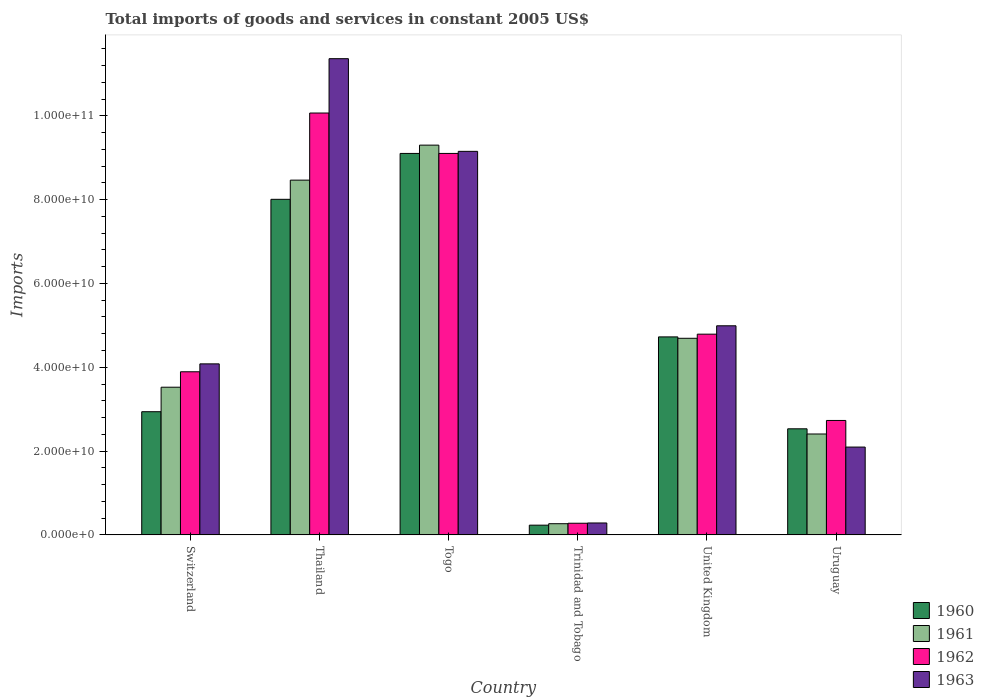Are the number of bars on each tick of the X-axis equal?
Your answer should be compact. Yes. How many bars are there on the 1st tick from the left?
Make the answer very short. 4. How many bars are there on the 4th tick from the right?
Provide a succinct answer. 4. What is the label of the 5th group of bars from the left?
Your answer should be very brief. United Kingdom. What is the total imports of goods and services in 1961 in Uruguay?
Provide a short and direct response. 2.41e+1. Across all countries, what is the maximum total imports of goods and services in 1961?
Keep it short and to the point. 9.30e+1. Across all countries, what is the minimum total imports of goods and services in 1963?
Keep it short and to the point. 2.85e+09. In which country was the total imports of goods and services in 1960 maximum?
Your response must be concise. Togo. In which country was the total imports of goods and services in 1961 minimum?
Your answer should be very brief. Trinidad and Tobago. What is the total total imports of goods and services in 1961 in the graph?
Your answer should be compact. 2.87e+11. What is the difference between the total imports of goods and services in 1961 in Trinidad and Tobago and that in Uruguay?
Your answer should be very brief. -2.14e+1. What is the difference between the total imports of goods and services in 1963 in United Kingdom and the total imports of goods and services in 1960 in Thailand?
Offer a terse response. -3.02e+1. What is the average total imports of goods and services in 1960 per country?
Provide a succinct answer. 4.59e+1. What is the difference between the total imports of goods and services of/in 1963 and total imports of goods and services of/in 1962 in Uruguay?
Provide a succinct answer. -6.35e+09. What is the ratio of the total imports of goods and services in 1960 in Switzerland to that in Uruguay?
Make the answer very short. 1.16. Is the difference between the total imports of goods and services in 1963 in Thailand and Trinidad and Tobago greater than the difference between the total imports of goods and services in 1962 in Thailand and Trinidad and Tobago?
Make the answer very short. Yes. What is the difference between the highest and the second highest total imports of goods and services in 1960?
Offer a terse response. -4.38e+1. What is the difference between the highest and the lowest total imports of goods and services in 1963?
Your answer should be very brief. 1.11e+11. Is the sum of the total imports of goods and services in 1963 in Thailand and Uruguay greater than the maximum total imports of goods and services in 1960 across all countries?
Offer a very short reply. Yes. What does the 4th bar from the right in Togo represents?
Your response must be concise. 1960. Is it the case that in every country, the sum of the total imports of goods and services in 1962 and total imports of goods and services in 1963 is greater than the total imports of goods and services in 1961?
Your answer should be compact. Yes. How many bars are there?
Your response must be concise. 24. Does the graph contain any zero values?
Make the answer very short. No. Does the graph contain grids?
Your answer should be very brief. No. Where does the legend appear in the graph?
Keep it short and to the point. Bottom right. How are the legend labels stacked?
Give a very brief answer. Vertical. What is the title of the graph?
Provide a short and direct response. Total imports of goods and services in constant 2005 US$. What is the label or title of the Y-axis?
Give a very brief answer. Imports. What is the Imports in 1960 in Switzerland?
Offer a terse response. 2.94e+1. What is the Imports in 1961 in Switzerland?
Offer a terse response. 3.52e+1. What is the Imports of 1962 in Switzerland?
Your answer should be compact. 3.89e+1. What is the Imports in 1963 in Switzerland?
Make the answer very short. 4.08e+1. What is the Imports of 1960 in Thailand?
Keep it short and to the point. 8.01e+1. What is the Imports of 1961 in Thailand?
Your answer should be very brief. 8.46e+1. What is the Imports in 1962 in Thailand?
Offer a very short reply. 1.01e+11. What is the Imports in 1963 in Thailand?
Make the answer very short. 1.14e+11. What is the Imports in 1960 in Togo?
Your response must be concise. 9.10e+1. What is the Imports in 1961 in Togo?
Give a very brief answer. 9.30e+1. What is the Imports in 1962 in Togo?
Provide a short and direct response. 9.10e+1. What is the Imports in 1963 in Togo?
Give a very brief answer. 9.15e+1. What is the Imports in 1960 in Trinidad and Tobago?
Provide a succinct answer. 2.32e+09. What is the Imports of 1961 in Trinidad and Tobago?
Your answer should be compact. 2.67e+09. What is the Imports in 1962 in Trinidad and Tobago?
Your answer should be compact. 2.78e+09. What is the Imports in 1963 in Trinidad and Tobago?
Your answer should be compact. 2.85e+09. What is the Imports of 1960 in United Kingdom?
Offer a terse response. 4.72e+1. What is the Imports in 1961 in United Kingdom?
Provide a short and direct response. 4.69e+1. What is the Imports in 1962 in United Kingdom?
Make the answer very short. 4.79e+1. What is the Imports of 1963 in United Kingdom?
Your answer should be compact. 4.99e+1. What is the Imports in 1960 in Uruguay?
Ensure brevity in your answer.  2.53e+1. What is the Imports of 1961 in Uruguay?
Provide a short and direct response. 2.41e+1. What is the Imports of 1962 in Uruguay?
Provide a succinct answer. 2.73e+1. What is the Imports of 1963 in Uruguay?
Your answer should be compact. 2.10e+1. Across all countries, what is the maximum Imports in 1960?
Your response must be concise. 9.10e+1. Across all countries, what is the maximum Imports in 1961?
Your answer should be compact. 9.30e+1. Across all countries, what is the maximum Imports in 1962?
Ensure brevity in your answer.  1.01e+11. Across all countries, what is the maximum Imports in 1963?
Provide a short and direct response. 1.14e+11. Across all countries, what is the minimum Imports in 1960?
Offer a very short reply. 2.32e+09. Across all countries, what is the minimum Imports of 1961?
Offer a terse response. 2.67e+09. Across all countries, what is the minimum Imports of 1962?
Make the answer very short. 2.78e+09. Across all countries, what is the minimum Imports in 1963?
Keep it short and to the point. 2.85e+09. What is the total Imports in 1960 in the graph?
Provide a short and direct response. 2.75e+11. What is the total Imports of 1961 in the graph?
Your answer should be very brief. 2.87e+11. What is the total Imports of 1962 in the graph?
Your answer should be very brief. 3.09e+11. What is the total Imports in 1963 in the graph?
Make the answer very short. 3.20e+11. What is the difference between the Imports of 1960 in Switzerland and that in Thailand?
Give a very brief answer. -5.07e+1. What is the difference between the Imports of 1961 in Switzerland and that in Thailand?
Your answer should be very brief. -4.94e+1. What is the difference between the Imports in 1962 in Switzerland and that in Thailand?
Make the answer very short. -6.17e+1. What is the difference between the Imports of 1963 in Switzerland and that in Thailand?
Offer a very short reply. -7.28e+1. What is the difference between the Imports in 1960 in Switzerland and that in Togo?
Offer a very short reply. -6.16e+1. What is the difference between the Imports of 1961 in Switzerland and that in Togo?
Give a very brief answer. -5.78e+1. What is the difference between the Imports of 1962 in Switzerland and that in Togo?
Ensure brevity in your answer.  -5.21e+1. What is the difference between the Imports in 1963 in Switzerland and that in Togo?
Your answer should be very brief. -5.07e+1. What is the difference between the Imports in 1960 in Switzerland and that in Trinidad and Tobago?
Offer a terse response. 2.71e+1. What is the difference between the Imports of 1961 in Switzerland and that in Trinidad and Tobago?
Your answer should be compact. 3.26e+1. What is the difference between the Imports of 1962 in Switzerland and that in Trinidad and Tobago?
Keep it short and to the point. 3.61e+1. What is the difference between the Imports in 1963 in Switzerland and that in Trinidad and Tobago?
Provide a succinct answer. 3.80e+1. What is the difference between the Imports in 1960 in Switzerland and that in United Kingdom?
Give a very brief answer. -1.79e+1. What is the difference between the Imports in 1961 in Switzerland and that in United Kingdom?
Offer a terse response. -1.17e+1. What is the difference between the Imports in 1962 in Switzerland and that in United Kingdom?
Give a very brief answer. -8.97e+09. What is the difference between the Imports in 1963 in Switzerland and that in United Kingdom?
Give a very brief answer. -9.09e+09. What is the difference between the Imports in 1960 in Switzerland and that in Uruguay?
Provide a short and direct response. 4.08e+09. What is the difference between the Imports of 1961 in Switzerland and that in Uruguay?
Provide a succinct answer. 1.12e+1. What is the difference between the Imports in 1962 in Switzerland and that in Uruguay?
Offer a very short reply. 1.16e+1. What is the difference between the Imports of 1963 in Switzerland and that in Uruguay?
Offer a very short reply. 1.99e+1. What is the difference between the Imports of 1960 in Thailand and that in Togo?
Keep it short and to the point. -1.09e+1. What is the difference between the Imports of 1961 in Thailand and that in Togo?
Offer a terse response. -8.35e+09. What is the difference between the Imports of 1962 in Thailand and that in Togo?
Provide a short and direct response. 9.64e+09. What is the difference between the Imports in 1963 in Thailand and that in Togo?
Make the answer very short. 2.21e+1. What is the difference between the Imports of 1960 in Thailand and that in Trinidad and Tobago?
Your answer should be compact. 7.77e+1. What is the difference between the Imports in 1961 in Thailand and that in Trinidad and Tobago?
Provide a succinct answer. 8.20e+1. What is the difference between the Imports of 1962 in Thailand and that in Trinidad and Tobago?
Give a very brief answer. 9.79e+1. What is the difference between the Imports of 1963 in Thailand and that in Trinidad and Tobago?
Ensure brevity in your answer.  1.11e+11. What is the difference between the Imports of 1960 in Thailand and that in United Kingdom?
Provide a short and direct response. 3.28e+1. What is the difference between the Imports of 1961 in Thailand and that in United Kingdom?
Offer a terse response. 3.77e+1. What is the difference between the Imports of 1962 in Thailand and that in United Kingdom?
Keep it short and to the point. 5.28e+1. What is the difference between the Imports in 1963 in Thailand and that in United Kingdom?
Keep it short and to the point. 6.37e+1. What is the difference between the Imports of 1960 in Thailand and that in Uruguay?
Give a very brief answer. 5.48e+1. What is the difference between the Imports in 1961 in Thailand and that in Uruguay?
Offer a very short reply. 6.06e+1. What is the difference between the Imports of 1962 in Thailand and that in Uruguay?
Give a very brief answer. 7.34e+1. What is the difference between the Imports of 1963 in Thailand and that in Uruguay?
Ensure brevity in your answer.  9.27e+1. What is the difference between the Imports of 1960 in Togo and that in Trinidad and Tobago?
Ensure brevity in your answer.  8.87e+1. What is the difference between the Imports in 1961 in Togo and that in Trinidad and Tobago?
Your answer should be very brief. 9.03e+1. What is the difference between the Imports of 1962 in Togo and that in Trinidad and Tobago?
Give a very brief answer. 8.82e+1. What is the difference between the Imports of 1963 in Togo and that in Trinidad and Tobago?
Offer a very short reply. 8.87e+1. What is the difference between the Imports in 1960 in Togo and that in United Kingdom?
Make the answer very short. 4.38e+1. What is the difference between the Imports in 1961 in Togo and that in United Kingdom?
Offer a very short reply. 4.61e+1. What is the difference between the Imports of 1962 in Togo and that in United Kingdom?
Offer a very short reply. 4.31e+1. What is the difference between the Imports of 1963 in Togo and that in United Kingdom?
Give a very brief answer. 4.16e+1. What is the difference between the Imports of 1960 in Togo and that in Uruguay?
Provide a short and direct response. 6.57e+1. What is the difference between the Imports of 1961 in Togo and that in Uruguay?
Your answer should be very brief. 6.89e+1. What is the difference between the Imports in 1962 in Togo and that in Uruguay?
Make the answer very short. 6.37e+1. What is the difference between the Imports of 1963 in Togo and that in Uruguay?
Keep it short and to the point. 7.06e+1. What is the difference between the Imports in 1960 in Trinidad and Tobago and that in United Kingdom?
Make the answer very short. -4.49e+1. What is the difference between the Imports of 1961 in Trinidad and Tobago and that in United Kingdom?
Provide a short and direct response. -4.42e+1. What is the difference between the Imports in 1962 in Trinidad and Tobago and that in United Kingdom?
Give a very brief answer. -4.51e+1. What is the difference between the Imports in 1963 in Trinidad and Tobago and that in United Kingdom?
Your answer should be compact. -4.70e+1. What is the difference between the Imports of 1960 in Trinidad and Tobago and that in Uruguay?
Your response must be concise. -2.30e+1. What is the difference between the Imports in 1961 in Trinidad and Tobago and that in Uruguay?
Provide a succinct answer. -2.14e+1. What is the difference between the Imports in 1962 in Trinidad and Tobago and that in Uruguay?
Ensure brevity in your answer.  -2.45e+1. What is the difference between the Imports in 1963 in Trinidad and Tobago and that in Uruguay?
Provide a succinct answer. -1.81e+1. What is the difference between the Imports of 1960 in United Kingdom and that in Uruguay?
Make the answer very short. 2.19e+1. What is the difference between the Imports of 1961 in United Kingdom and that in Uruguay?
Give a very brief answer. 2.28e+1. What is the difference between the Imports of 1962 in United Kingdom and that in Uruguay?
Make the answer very short. 2.06e+1. What is the difference between the Imports in 1963 in United Kingdom and that in Uruguay?
Your response must be concise. 2.89e+1. What is the difference between the Imports in 1960 in Switzerland and the Imports in 1961 in Thailand?
Your answer should be very brief. -5.53e+1. What is the difference between the Imports of 1960 in Switzerland and the Imports of 1962 in Thailand?
Provide a short and direct response. -7.13e+1. What is the difference between the Imports of 1960 in Switzerland and the Imports of 1963 in Thailand?
Your answer should be very brief. -8.42e+1. What is the difference between the Imports of 1961 in Switzerland and the Imports of 1962 in Thailand?
Keep it short and to the point. -6.54e+1. What is the difference between the Imports in 1961 in Switzerland and the Imports in 1963 in Thailand?
Offer a very short reply. -7.84e+1. What is the difference between the Imports in 1962 in Switzerland and the Imports in 1963 in Thailand?
Your answer should be very brief. -7.47e+1. What is the difference between the Imports of 1960 in Switzerland and the Imports of 1961 in Togo?
Provide a succinct answer. -6.36e+1. What is the difference between the Imports in 1960 in Switzerland and the Imports in 1962 in Togo?
Your answer should be very brief. -6.16e+1. What is the difference between the Imports of 1960 in Switzerland and the Imports of 1963 in Togo?
Make the answer very short. -6.21e+1. What is the difference between the Imports in 1961 in Switzerland and the Imports in 1962 in Togo?
Offer a terse response. -5.58e+1. What is the difference between the Imports in 1961 in Switzerland and the Imports in 1963 in Togo?
Provide a succinct answer. -5.63e+1. What is the difference between the Imports in 1962 in Switzerland and the Imports in 1963 in Togo?
Your answer should be very brief. -5.26e+1. What is the difference between the Imports in 1960 in Switzerland and the Imports in 1961 in Trinidad and Tobago?
Provide a succinct answer. 2.67e+1. What is the difference between the Imports of 1960 in Switzerland and the Imports of 1962 in Trinidad and Tobago?
Offer a terse response. 2.66e+1. What is the difference between the Imports of 1960 in Switzerland and the Imports of 1963 in Trinidad and Tobago?
Offer a very short reply. 2.65e+1. What is the difference between the Imports in 1961 in Switzerland and the Imports in 1962 in Trinidad and Tobago?
Keep it short and to the point. 3.25e+1. What is the difference between the Imports in 1961 in Switzerland and the Imports in 1963 in Trinidad and Tobago?
Your response must be concise. 3.24e+1. What is the difference between the Imports in 1962 in Switzerland and the Imports in 1963 in Trinidad and Tobago?
Provide a short and direct response. 3.61e+1. What is the difference between the Imports in 1960 in Switzerland and the Imports in 1961 in United Kingdom?
Your answer should be compact. -1.75e+1. What is the difference between the Imports in 1960 in Switzerland and the Imports in 1962 in United Kingdom?
Offer a very short reply. -1.85e+1. What is the difference between the Imports in 1960 in Switzerland and the Imports in 1963 in United Kingdom?
Offer a terse response. -2.05e+1. What is the difference between the Imports of 1961 in Switzerland and the Imports of 1962 in United Kingdom?
Your answer should be very brief. -1.27e+1. What is the difference between the Imports of 1961 in Switzerland and the Imports of 1963 in United Kingdom?
Your answer should be very brief. -1.47e+1. What is the difference between the Imports in 1962 in Switzerland and the Imports in 1963 in United Kingdom?
Your answer should be compact. -1.10e+1. What is the difference between the Imports in 1960 in Switzerland and the Imports in 1961 in Uruguay?
Make the answer very short. 5.31e+09. What is the difference between the Imports in 1960 in Switzerland and the Imports in 1962 in Uruguay?
Keep it short and to the point. 2.09e+09. What is the difference between the Imports of 1960 in Switzerland and the Imports of 1963 in Uruguay?
Offer a terse response. 8.44e+09. What is the difference between the Imports in 1961 in Switzerland and the Imports in 1962 in Uruguay?
Provide a short and direct response. 7.93e+09. What is the difference between the Imports in 1961 in Switzerland and the Imports in 1963 in Uruguay?
Your response must be concise. 1.43e+1. What is the difference between the Imports of 1962 in Switzerland and the Imports of 1963 in Uruguay?
Offer a very short reply. 1.80e+1. What is the difference between the Imports of 1960 in Thailand and the Imports of 1961 in Togo?
Offer a very short reply. -1.29e+1. What is the difference between the Imports of 1960 in Thailand and the Imports of 1962 in Togo?
Offer a very short reply. -1.09e+1. What is the difference between the Imports in 1960 in Thailand and the Imports in 1963 in Togo?
Your answer should be compact. -1.14e+1. What is the difference between the Imports in 1961 in Thailand and the Imports in 1962 in Togo?
Your answer should be very brief. -6.37e+09. What is the difference between the Imports in 1961 in Thailand and the Imports in 1963 in Togo?
Your response must be concise. -6.87e+09. What is the difference between the Imports in 1962 in Thailand and the Imports in 1963 in Togo?
Offer a terse response. 9.15e+09. What is the difference between the Imports in 1960 in Thailand and the Imports in 1961 in Trinidad and Tobago?
Your answer should be very brief. 7.74e+1. What is the difference between the Imports in 1960 in Thailand and the Imports in 1962 in Trinidad and Tobago?
Ensure brevity in your answer.  7.73e+1. What is the difference between the Imports of 1960 in Thailand and the Imports of 1963 in Trinidad and Tobago?
Offer a terse response. 7.72e+1. What is the difference between the Imports in 1961 in Thailand and the Imports in 1962 in Trinidad and Tobago?
Make the answer very short. 8.19e+1. What is the difference between the Imports in 1961 in Thailand and the Imports in 1963 in Trinidad and Tobago?
Give a very brief answer. 8.18e+1. What is the difference between the Imports of 1962 in Thailand and the Imports of 1963 in Trinidad and Tobago?
Make the answer very short. 9.78e+1. What is the difference between the Imports of 1960 in Thailand and the Imports of 1961 in United Kingdom?
Make the answer very short. 3.32e+1. What is the difference between the Imports of 1960 in Thailand and the Imports of 1962 in United Kingdom?
Your answer should be compact. 3.22e+1. What is the difference between the Imports in 1960 in Thailand and the Imports in 1963 in United Kingdom?
Make the answer very short. 3.02e+1. What is the difference between the Imports of 1961 in Thailand and the Imports of 1962 in United Kingdom?
Offer a terse response. 3.68e+1. What is the difference between the Imports of 1961 in Thailand and the Imports of 1963 in United Kingdom?
Your response must be concise. 3.48e+1. What is the difference between the Imports of 1962 in Thailand and the Imports of 1963 in United Kingdom?
Provide a succinct answer. 5.08e+1. What is the difference between the Imports in 1960 in Thailand and the Imports in 1961 in Uruguay?
Give a very brief answer. 5.60e+1. What is the difference between the Imports of 1960 in Thailand and the Imports of 1962 in Uruguay?
Your answer should be compact. 5.28e+1. What is the difference between the Imports in 1960 in Thailand and the Imports in 1963 in Uruguay?
Your answer should be compact. 5.91e+1. What is the difference between the Imports in 1961 in Thailand and the Imports in 1962 in Uruguay?
Your answer should be compact. 5.73e+1. What is the difference between the Imports of 1961 in Thailand and the Imports of 1963 in Uruguay?
Provide a succinct answer. 6.37e+1. What is the difference between the Imports in 1962 in Thailand and the Imports in 1963 in Uruguay?
Provide a succinct answer. 7.97e+1. What is the difference between the Imports in 1960 in Togo and the Imports in 1961 in Trinidad and Tobago?
Your response must be concise. 8.84e+1. What is the difference between the Imports in 1960 in Togo and the Imports in 1962 in Trinidad and Tobago?
Give a very brief answer. 8.82e+1. What is the difference between the Imports of 1960 in Togo and the Imports of 1963 in Trinidad and Tobago?
Provide a short and direct response. 8.82e+1. What is the difference between the Imports of 1961 in Togo and the Imports of 1962 in Trinidad and Tobago?
Your answer should be compact. 9.02e+1. What is the difference between the Imports of 1961 in Togo and the Imports of 1963 in Trinidad and Tobago?
Provide a succinct answer. 9.02e+1. What is the difference between the Imports of 1962 in Togo and the Imports of 1963 in Trinidad and Tobago?
Your answer should be compact. 8.82e+1. What is the difference between the Imports in 1960 in Togo and the Imports in 1961 in United Kingdom?
Your answer should be very brief. 4.41e+1. What is the difference between the Imports of 1960 in Togo and the Imports of 1962 in United Kingdom?
Offer a terse response. 4.31e+1. What is the difference between the Imports in 1960 in Togo and the Imports in 1963 in United Kingdom?
Ensure brevity in your answer.  4.11e+1. What is the difference between the Imports of 1961 in Togo and the Imports of 1962 in United Kingdom?
Your answer should be compact. 4.51e+1. What is the difference between the Imports in 1961 in Togo and the Imports in 1963 in United Kingdom?
Your answer should be very brief. 4.31e+1. What is the difference between the Imports in 1962 in Togo and the Imports in 1963 in United Kingdom?
Your answer should be very brief. 4.11e+1. What is the difference between the Imports of 1960 in Togo and the Imports of 1961 in Uruguay?
Offer a very short reply. 6.69e+1. What is the difference between the Imports of 1960 in Togo and the Imports of 1962 in Uruguay?
Provide a succinct answer. 6.37e+1. What is the difference between the Imports of 1960 in Togo and the Imports of 1963 in Uruguay?
Provide a succinct answer. 7.01e+1. What is the difference between the Imports in 1961 in Togo and the Imports in 1962 in Uruguay?
Your answer should be compact. 6.57e+1. What is the difference between the Imports of 1961 in Togo and the Imports of 1963 in Uruguay?
Your answer should be compact. 7.20e+1. What is the difference between the Imports in 1962 in Togo and the Imports in 1963 in Uruguay?
Provide a short and direct response. 7.01e+1. What is the difference between the Imports in 1960 in Trinidad and Tobago and the Imports in 1961 in United Kingdom?
Offer a terse response. -4.46e+1. What is the difference between the Imports in 1960 in Trinidad and Tobago and the Imports in 1962 in United Kingdom?
Provide a short and direct response. -4.56e+1. What is the difference between the Imports of 1960 in Trinidad and Tobago and the Imports of 1963 in United Kingdom?
Keep it short and to the point. -4.76e+1. What is the difference between the Imports of 1961 in Trinidad and Tobago and the Imports of 1962 in United Kingdom?
Provide a short and direct response. -4.52e+1. What is the difference between the Imports in 1961 in Trinidad and Tobago and the Imports in 1963 in United Kingdom?
Your answer should be compact. -4.72e+1. What is the difference between the Imports in 1962 in Trinidad and Tobago and the Imports in 1963 in United Kingdom?
Offer a terse response. -4.71e+1. What is the difference between the Imports in 1960 in Trinidad and Tobago and the Imports in 1961 in Uruguay?
Your answer should be compact. -2.18e+1. What is the difference between the Imports of 1960 in Trinidad and Tobago and the Imports of 1962 in Uruguay?
Provide a succinct answer. -2.50e+1. What is the difference between the Imports of 1960 in Trinidad and Tobago and the Imports of 1963 in Uruguay?
Offer a terse response. -1.86e+1. What is the difference between the Imports in 1961 in Trinidad and Tobago and the Imports in 1962 in Uruguay?
Your response must be concise. -2.46e+1. What is the difference between the Imports of 1961 in Trinidad and Tobago and the Imports of 1963 in Uruguay?
Keep it short and to the point. -1.83e+1. What is the difference between the Imports of 1962 in Trinidad and Tobago and the Imports of 1963 in Uruguay?
Offer a very short reply. -1.82e+1. What is the difference between the Imports of 1960 in United Kingdom and the Imports of 1961 in Uruguay?
Give a very brief answer. 2.32e+1. What is the difference between the Imports of 1960 in United Kingdom and the Imports of 1962 in Uruguay?
Make the answer very short. 1.99e+1. What is the difference between the Imports in 1960 in United Kingdom and the Imports in 1963 in Uruguay?
Ensure brevity in your answer.  2.63e+1. What is the difference between the Imports in 1961 in United Kingdom and the Imports in 1962 in Uruguay?
Keep it short and to the point. 1.96e+1. What is the difference between the Imports of 1961 in United Kingdom and the Imports of 1963 in Uruguay?
Offer a terse response. 2.60e+1. What is the difference between the Imports in 1962 in United Kingdom and the Imports in 1963 in Uruguay?
Keep it short and to the point. 2.69e+1. What is the average Imports of 1960 per country?
Your answer should be compact. 4.59e+1. What is the average Imports in 1961 per country?
Ensure brevity in your answer.  4.78e+1. What is the average Imports of 1962 per country?
Your answer should be compact. 5.14e+1. What is the average Imports of 1963 per country?
Provide a succinct answer. 5.33e+1. What is the difference between the Imports of 1960 and Imports of 1961 in Switzerland?
Your answer should be very brief. -5.85e+09. What is the difference between the Imports of 1960 and Imports of 1962 in Switzerland?
Your answer should be very brief. -9.53e+09. What is the difference between the Imports of 1960 and Imports of 1963 in Switzerland?
Your response must be concise. -1.14e+1. What is the difference between the Imports in 1961 and Imports in 1962 in Switzerland?
Give a very brief answer. -3.69e+09. What is the difference between the Imports in 1961 and Imports in 1963 in Switzerland?
Provide a short and direct response. -5.57e+09. What is the difference between the Imports in 1962 and Imports in 1963 in Switzerland?
Your response must be concise. -1.88e+09. What is the difference between the Imports of 1960 and Imports of 1961 in Thailand?
Provide a succinct answer. -4.58e+09. What is the difference between the Imports of 1960 and Imports of 1962 in Thailand?
Ensure brevity in your answer.  -2.06e+1. What is the difference between the Imports of 1960 and Imports of 1963 in Thailand?
Provide a short and direct response. -3.36e+1. What is the difference between the Imports in 1961 and Imports in 1962 in Thailand?
Offer a very short reply. -1.60e+1. What is the difference between the Imports in 1961 and Imports in 1963 in Thailand?
Ensure brevity in your answer.  -2.90e+1. What is the difference between the Imports of 1962 and Imports of 1963 in Thailand?
Ensure brevity in your answer.  -1.30e+1. What is the difference between the Imports of 1960 and Imports of 1961 in Togo?
Offer a terse response. -1.98e+09. What is the difference between the Imports in 1960 and Imports in 1963 in Togo?
Make the answer very short. -4.94e+08. What is the difference between the Imports in 1961 and Imports in 1962 in Togo?
Ensure brevity in your answer.  1.98e+09. What is the difference between the Imports in 1961 and Imports in 1963 in Togo?
Provide a succinct answer. 1.48e+09. What is the difference between the Imports of 1962 and Imports of 1963 in Togo?
Provide a succinct answer. -4.94e+08. What is the difference between the Imports in 1960 and Imports in 1961 in Trinidad and Tobago?
Your response must be concise. -3.48e+08. What is the difference between the Imports of 1960 and Imports of 1962 in Trinidad and Tobago?
Keep it short and to the point. -4.60e+08. What is the difference between the Imports of 1960 and Imports of 1963 in Trinidad and Tobago?
Make the answer very short. -5.24e+08. What is the difference between the Imports in 1961 and Imports in 1962 in Trinidad and Tobago?
Offer a very short reply. -1.12e+08. What is the difference between the Imports in 1961 and Imports in 1963 in Trinidad and Tobago?
Provide a succinct answer. -1.77e+08. What is the difference between the Imports of 1962 and Imports of 1963 in Trinidad and Tobago?
Offer a very short reply. -6.48e+07. What is the difference between the Imports in 1960 and Imports in 1961 in United Kingdom?
Offer a very short reply. 3.32e+08. What is the difference between the Imports in 1960 and Imports in 1962 in United Kingdom?
Provide a succinct answer. -6.50e+08. What is the difference between the Imports of 1960 and Imports of 1963 in United Kingdom?
Ensure brevity in your answer.  -2.65e+09. What is the difference between the Imports of 1961 and Imports of 1962 in United Kingdom?
Provide a succinct answer. -9.83e+08. What is the difference between the Imports of 1961 and Imports of 1963 in United Kingdom?
Provide a succinct answer. -2.98e+09. What is the difference between the Imports of 1962 and Imports of 1963 in United Kingdom?
Offer a terse response. -2.00e+09. What is the difference between the Imports in 1960 and Imports in 1961 in Uruguay?
Your answer should be very brief. 1.24e+09. What is the difference between the Imports in 1960 and Imports in 1962 in Uruguay?
Ensure brevity in your answer.  -1.99e+09. What is the difference between the Imports in 1960 and Imports in 1963 in Uruguay?
Offer a very short reply. 4.36e+09. What is the difference between the Imports of 1961 and Imports of 1962 in Uruguay?
Ensure brevity in your answer.  -3.23e+09. What is the difference between the Imports of 1961 and Imports of 1963 in Uruguay?
Your answer should be very brief. 3.12e+09. What is the difference between the Imports in 1962 and Imports in 1963 in Uruguay?
Make the answer very short. 6.35e+09. What is the ratio of the Imports of 1960 in Switzerland to that in Thailand?
Offer a terse response. 0.37. What is the ratio of the Imports in 1961 in Switzerland to that in Thailand?
Provide a short and direct response. 0.42. What is the ratio of the Imports in 1962 in Switzerland to that in Thailand?
Make the answer very short. 0.39. What is the ratio of the Imports in 1963 in Switzerland to that in Thailand?
Offer a very short reply. 0.36. What is the ratio of the Imports of 1960 in Switzerland to that in Togo?
Provide a succinct answer. 0.32. What is the ratio of the Imports of 1961 in Switzerland to that in Togo?
Offer a very short reply. 0.38. What is the ratio of the Imports of 1962 in Switzerland to that in Togo?
Ensure brevity in your answer.  0.43. What is the ratio of the Imports in 1963 in Switzerland to that in Togo?
Your answer should be compact. 0.45. What is the ratio of the Imports of 1960 in Switzerland to that in Trinidad and Tobago?
Offer a terse response. 12.66. What is the ratio of the Imports in 1961 in Switzerland to that in Trinidad and Tobago?
Give a very brief answer. 13.2. What is the ratio of the Imports in 1962 in Switzerland to that in Trinidad and Tobago?
Ensure brevity in your answer.  14. What is the ratio of the Imports in 1963 in Switzerland to that in Trinidad and Tobago?
Give a very brief answer. 14.34. What is the ratio of the Imports of 1960 in Switzerland to that in United Kingdom?
Make the answer very short. 0.62. What is the ratio of the Imports of 1961 in Switzerland to that in United Kingdom?
Offer a very short reply. 0.75. What is the ratio of the Imports of 1962 in Switzerland to that in United Kingdom?
Provide a short and direct response. 0.81. What is the ratio of the Imports in 1963 in Switzerland to that in United Kingdom?
Your answer should be very brief. 0.82. What is the ratio of the Imports in 1960 in Switzerland to that in Uruguay?
Offer a very short reply. 1.16. What is the ratio of the Imports in 1961 in Switzerland to that in Uruguay?
Keep it short and to the point. 1.46. What is the ratio of the Imports of 1962 in Switzerland to that in Uruguay?
Your response must be concise. 1.43. What is the ratio of the Imports of 1963 in Switzerland to that in Uruguay?
Offer a very short reply. 1.95. What is the ratio of the Imports in 1960 in Thailand to that in Togo?
Your answer should be compact. 0.88. What is the ratio of the Imports in 1961 in Thailand to that in Togo?
Give a very brief answer. 0.91. What is the ratio of the Imports of 1962 in Thailand to that in Togo?
Keep it short and to the point. 1.11. What is the ratio of the Imports in 1963 in Thailand to that in Togo?
Keep it short and to the point. 1.24. What is the ratio of the Imports of 1960 in Thailand to that in Trinidad and Tobago?
Provide a short and direct response. 34.5. What is the ratio of the Imports of 1961 in Thailand to that in Trinidad and Tobago?
Ensure brevity in your answer.  31.72. What is the ratio of the Imports in 1962 in Thailand to that in Trinidad and Tobago?
Ensure brevity in your answer.  36.2. What is the ratio of the Imports in 1963 in Thailand to that in Trinidad and Tobago?
Keep it short and to the point. 39.93. What is the ratio of the Imports in 1960 in Thailand to that in United Kingdom?
Give a very brief answer. 1.69. What is the ratio of the Imports of 1961 in Thailand to that in United Kingdom?
Make the answer very short. 1.8. What is the ratio of the Imports in 1962 in Thailand to that in United Kingdom?
Provide a succinct answer. 2.1. What is the ratio of the Imports of 1963 in Thailand to that in United Kingdom?
Your answer should be very brief. 2.28. What is the ratio of the Imports of 1960 in Thailand to that in Uruguay?
Provide a short and direct response. 3.16. What is the ratio of the Imports of 1961 in Thailand to that in Uruguay?
Provide a succinct answer. 3.52. What is the ratio of the Imports in 1962 in Thailand to that in Uruguay?
Your answer should be very brief. 3.69. What is the ratio of the Imports in 1963 in Thailand to that in Uruguay?
Give a very brief answer. 5.42. What is the ratio of the Imports in 1960 in Togo to that in Trinidad and Tobago?
Ensure brevity in your answer.  39.21. What is the ratio of the Imports in 1961 in Togo to that in Trinidad and Tobago?
Offer a very short reply. 34.85. What is the ratio of the Imports of 1962 in Togo to that in Trinidad and Tobago?
Offer a very short reply. 32.73. What is the ratio of the Imports in 1963 in Togo to that in Trinidad and Tobago?
Your answer should be compact. 32.16. What is the ratio of the Imports in 1960 in Togo to that in United Kingdom?
Your answer should be very brief. 1.93. What is the ratio of the Imports of 1961 in Togo to that in United Kingdom?
Keep it short and to the point. 1.98. What is the ratio of the Imports in 1962 in Togo to that in United Kingdom?
Give a very brief answer. 1.9. What is the ratio of the Imports of 1963 in Togo to that in United Kingdom?
Your answer should be very brief. 1.83. What is the ratio of the Imports in 1960 in Togo to that in Uruguay?
Offer a terse response. 3.6. What is the ratio of the Imports of 1961 in Togo to that in Uruguay?
Make the answer very short. 3.86. What is the ratio of the Imports in 1962 in Togo to that in Uruguay?
Provide a short and direct response. 3.33. What is the ratio of the Imports in 1963 in Togo to that in Uruguay?
Offer a terse response. 4.37. What is the ratio of the Imports of 1960 in Trinidad and Tobago to that in United Kingdom?
Provide a succinct answer. 0.05. What is the ratio of the Imports of 1961 in Trinidad and Tobago to that in United Kingdom?
Ensure brevity in your answer.  0.06. What is the ratio of the Imports of 1962 in Trinidad and Tobago to that in United Kingdom?
Make the answer very short. 0.06. What is the ratio of the Imports of 1963 in Trinidad and Tobago to that in United Kingdom?
Your response must be concise. 0.06. What is the ratio of the Imports of 1960 in Trinidad and Tobago to that in Uruguay?
Provide a succinct answer. 0.09. What is the ratio of the Imports in 1961 in Trinidad and Tobago to that in Uruguay?
Make the answer very short. 0.11. What is the ratio of the Imports of 1962 in Trinidad and Tobago to that in Uruguay?
Give a very brief answer. 0.1. What is the ratio of the Imports of 1963 in Trinidad and Tobago to that in Uruguay?
Keep it short and to the point. 0.14. What is the ratio of the Imports in 1960 in United Kingdom to that in Uruguay?
Keep it short and to the point. 1.87. What is the ratio of the Imports of 1961 in United Kingdom to that in Uruguay?
Provide a succinct answer. 1.95. What is the ratio of the Imports in 1962 in United Kingdom to that in Uruguay?
Your answer should be very brief. 1.75. What is the ratio of the Imports in 1963 in United Kingdom to that in Uruguay?
Your response must be concise. 2.38. What is the difference between the highest and the second highest Imports of 1960?
Give a very brief answer. 1.09e+1. What is the difference between the highest and the second highest Imports in 1961?
Make the answer very short. 8.35e+09. What is the difference between the highest and the second highest Imports of 1962?
Make the answer very short. 9.64e+09. What is the difference between the highest and the second highest Imports of 1963?
Provide a short and direct response. 2.21e+1. What is the difference between the highest and the lowest Imports of 1960?
Provide a short and direct response. 8.87e+1. What is the difference between the highest and the lowest Imports of 1961?
Your answer should be very brief. 9.03e+1. What is the difference between the highest and the lowest Imports of 1962?
Give a very brief answer. 9.79e+1. What is the difference between the highest and the lowest Imports of 1963?
Provide a succinct answer. 1.11e+11. 